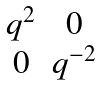Convert formula to latex. <formula><loc_0><loc_0><loc_500><loc_500>\begin{matrix} q ^ { 2 } & 0 \\ 0 & q ^ { - 2 } \end{matrix}</formula> 